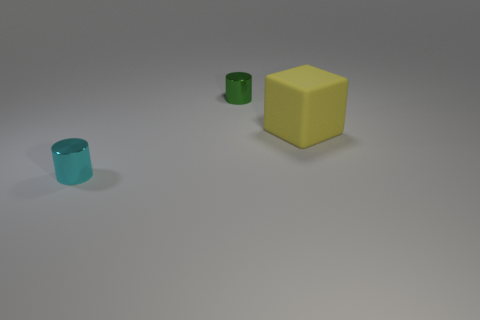Add 3 tiny green cylinders. How many objects exist? 6 Subtract all blocks. How many objects are left? 2 Add 1 blue balls. How many blue balls exist? 1 Subtract 0 purple blocks. How many objects are left? 3 Subtract all tiny cylinders. Subtract all cyan objects. How many objects are left? 0 Add 3 small objects. How many small objects are left? 5 